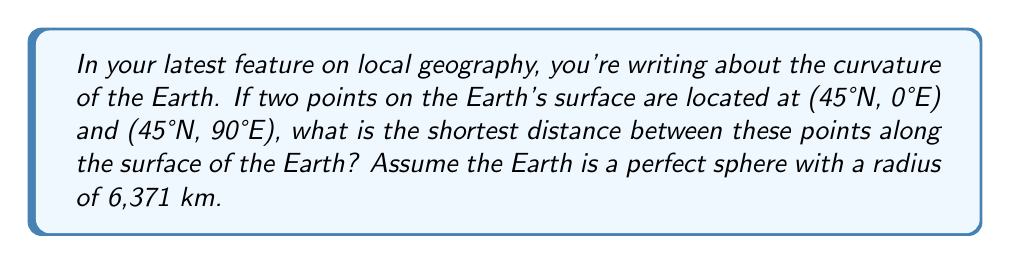Solve this math problem. To solve this problem, we need to use the concept of great circle distance on a sphere. The shortest path between two points on a sphere always lies on a great circle. Here's how we can calculate it:

1) First, we need to convert the coordinates to radians:
   $\phi_1 = \phi_2 = 45° \cdot \frac{\pi}{180°} = \frac{\pi}{4}$ (latitude)
   $\lambda_1 = 0$, $\lambda_2 = 90° \cdot \frac{\pi}{180°} = \frac{\pi}{2}$ (longitude)

2) The central angle $\Delta\sigma$ between two points on a sphere can be calculated using the haversine formula:

   $$\Delta\sigma = 2 \arcsin\left(\sqrt{\sin^2\left(\frac{\Delta\phi}{2}\right) + \cos\phi_1 \cos\phi_2 \sin^2\left(\frac{\Delta\lambda}{2}\right)}\right)$$

   Where $\Delta\phi = \phi_2 - \phi_1$ and $\Delta\lambda = \lambda_2 - \lambda_1$

3) In our case, $\Delta\phi = 0$ and $\Delta\lambda = \frac{\pi}{2}$, so:

   $$\Delta\sigma = 2 \arcsin\left(\sqrt{\sin^2(0) + \cos\frac{\pi}{4} \cos\frac{\pi}{4} \sin^2\left(\frac{\pi}{4}\right)}\right)$$

4) Simplifying:
   $$\Delta\sigma = 2 \arcsin\left(\sqrt{\frac{1}{2} \cdot \frac{1}{2}}\right) = 2 \arcsin\left(\frac{1}{\sqrt{2}}\right) = \frac{\pi}{2}$$

5) The distance $d$ along the great circle is then:
   $$d = R \cdot \Delta\sigma$$
   Where $R$ is the radius of the Earth (6,371 km)

6) Therefore:
   $$d = 6371 \cdot \frac{\pi}{2} \approx 10,007.5 \text{ km}$$
Answer: 10,007.5 km 